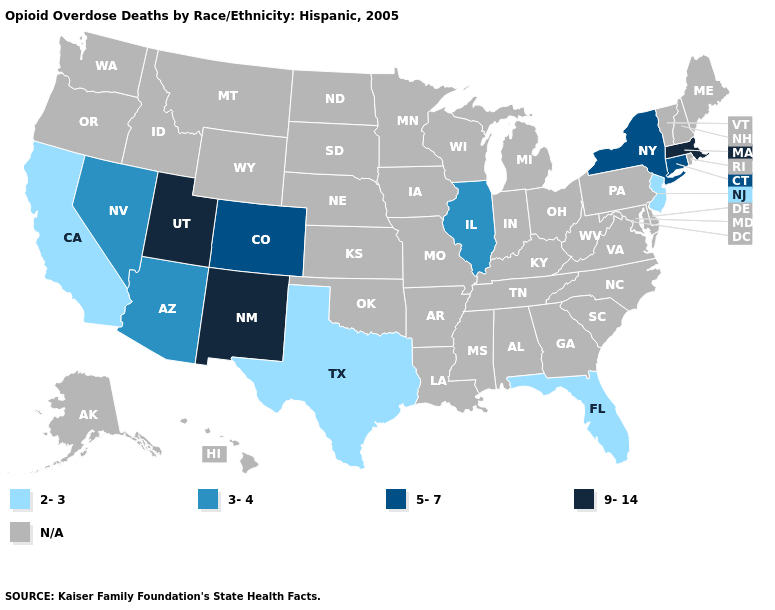Which states have the lowest value in the West?
Write a very short answer. California. Name the states that have a value in the range 5-7?
Be succinct. Colorado, Connecticut, New York. What is the lowest value in the USA?
Write a very short answer. 2-3. What is the value of New York?
Keep it brief. 5-7. Which states have the lowest value in the MidWest?
Quick response, please. Illinois. Which states have the lowest value in the South?
Short answer required. Florida, Texas. What is the lowest value in the South?
Write a very short answer. 2-3. What is the lowest value in the Northeast?
Be succinct. 2-3. How many symbols are there in the legend?
Write a very short answer. 5. What is the value of Missouri?
Concise answer only. N/A. Name the states that have a value in the range 2-3?
Be succinct. California, Florida, New Jersey, Texas. Which states have the highest value in the USA?
Keep it brief. Massachusetts, New Mexico, Utah. What is the lowest value in the USA?
Quick response, please. 2-3. 